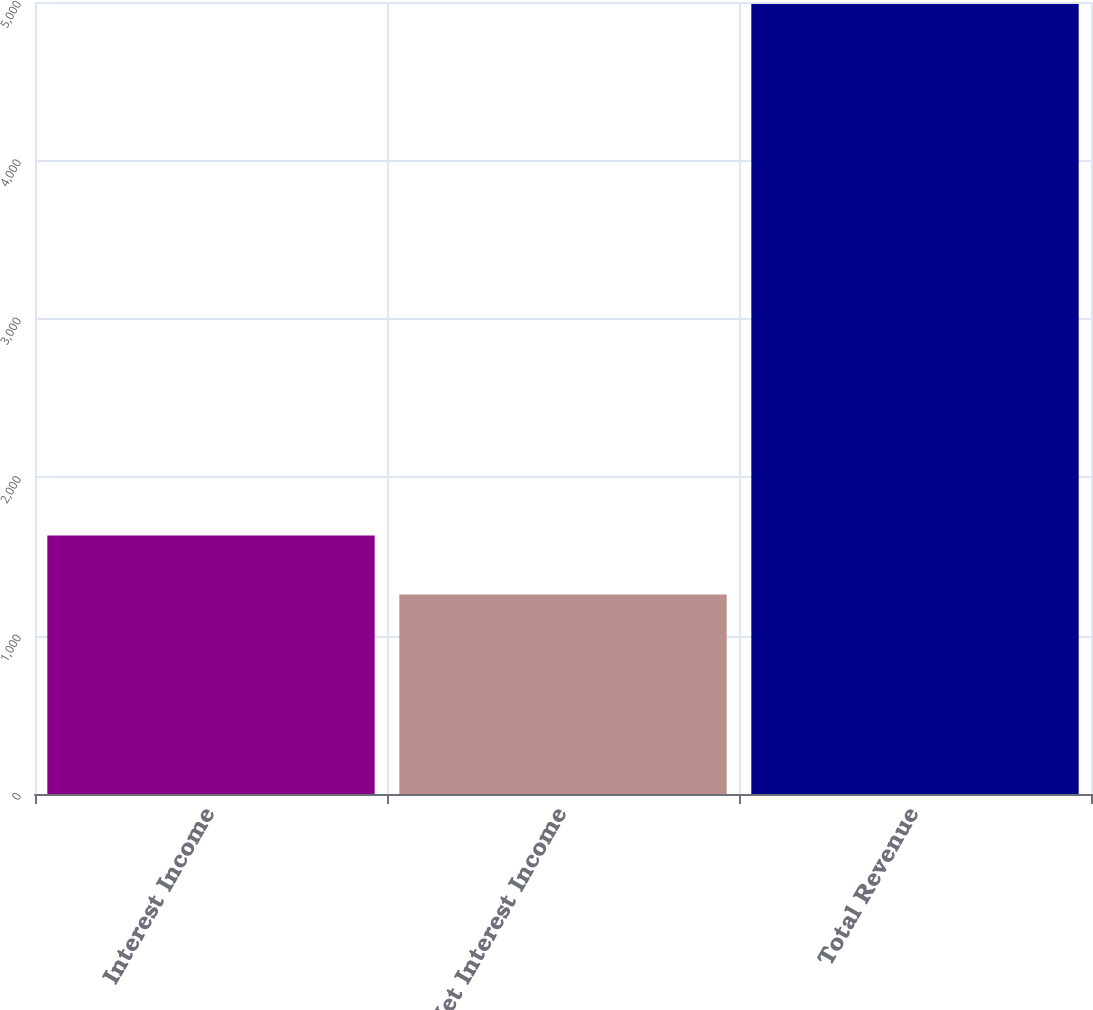Convert chart. <chart><loc_0><loc_0><loc_500><loc_500><bar_chart><fcel>Interest Income<fcel>Net Interest Income<fcel>Total Revenue<nl><fcel>1632.69<fcel>1260<fcel>4986.9<nl></chart> 